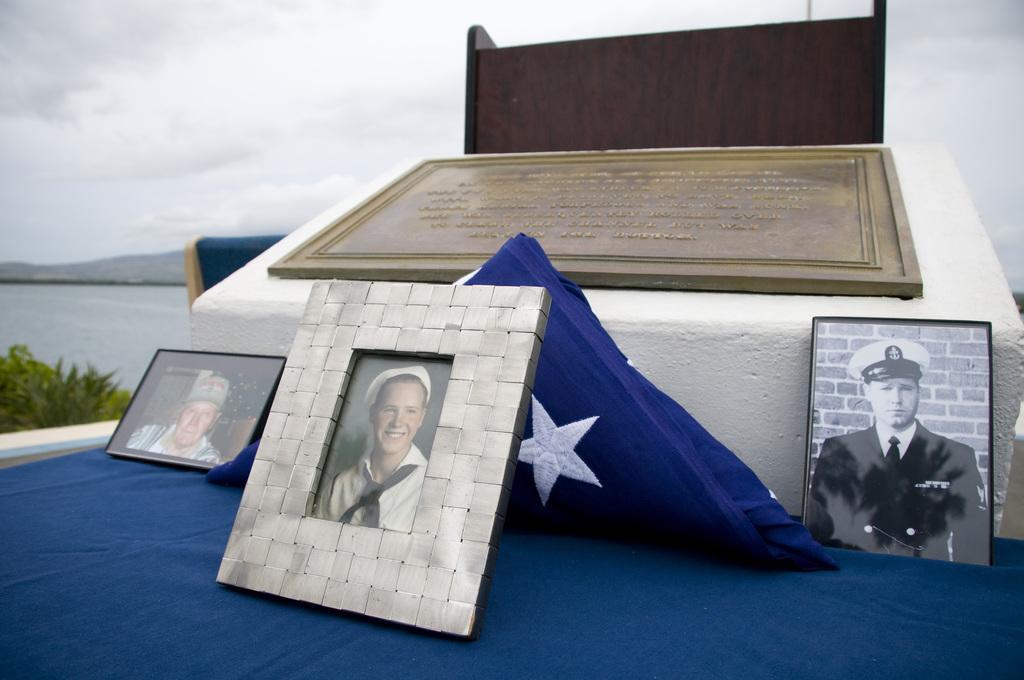Can you describe this image briefly? In this image, we can see photo frames are on the cloth. Here we can see a blue cloth, frame and wooden object. Background we can see the sky. On the left side, we can see plants, water and hill. 